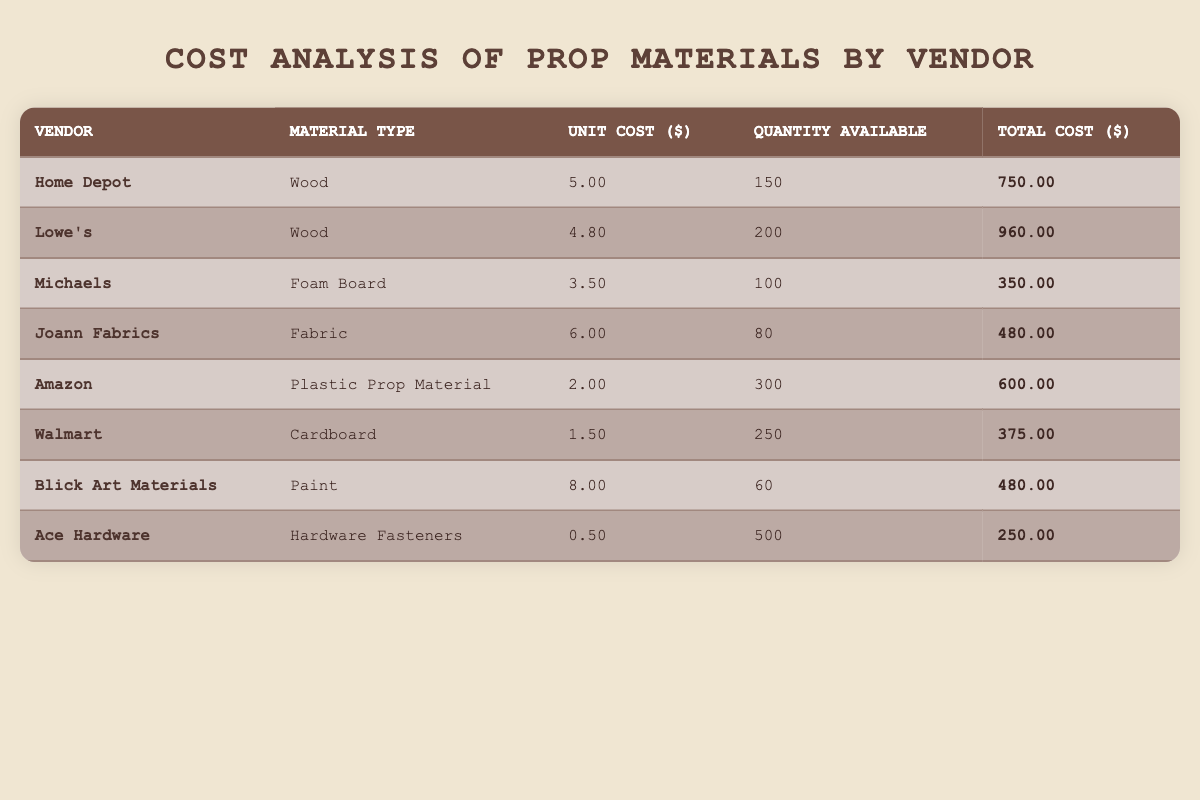What is the unit cost of Wood from Lowe's? The table lists Lowe's under the vendor column, and the corresponding unit cost, located in the same row, is $4.80.
Answer: 4.80 Which vendor offers the lowest unit cost for any material? The lowest unit cost listed in the table is for Ace Hardware offering Hardware Fasteners at $0.50, making it the vendor with the lowest unit cost for any material.
Answer: Ace Hardware How much more does it cost to buy 150 units of Wood from Home Depot compared to Walmart's Cardboard unit price? Home Depot's unit cost for Wood is $5.00; for Walmart's Cardboard, it's $1.50. The difference is $5.00 - $1.50 = $3.50. Therefore, for 150 units, the total cost at Home Depot would be 150 x $5.00 = $750.00 and at Walmart it would be 150 x $1.50 = $225.00. The difference in total cost is $750.00 - $225.00 = $525.00.
Answer: 525.00 Is the total cost of Fabirc from Joann Fabrics less than that of Foam Board from Michaels? Joann Fabrics' total cost for Fabric is $480, while Michaels' total cost for Foam Board is $350. Since $480 is greater than $350, the statement is false.
Answer: No What is the total number of units available across all vendors for Plastic Prop Material? The table indicates that Amazon offers 300 units of Plastic Prop Material, and it is the only vendor for this material. Therefore, the total number of units available is simply that figure: 300.
Answer: 300 What is the average unit cost of all materials listed in the table? To find the average unit cost, sum up all unit costs: 5.00 (Home Depot) + 4.80 (Lowe's) + 3.50 (Michaels) + 6.00 (Joann Fabrics) + 2.00 (Amazon) + 1.50 (Walmart) + 8.00 (Blick Art Materials) + 0.50 (Ace Hardware) = 31.30. Then, divide by the number of materials, which is 8. The average is 31.30 / 8 = 3.91.
Answer: 3.91 Which vendor has the highest quantity available, and how many units do they have? The vendor with the highest quantity available is Ace Hardware, listed with 500 units of Hardware Fasteners in the corresponding row of the table.
Answer: Ace Hardware; 500 What is the total cost of the materials from Blick Art Materials and Joann Fabrics combined? Blick Art Materials has a total cost of $480 for Paint and Joann Fabrics has a total cost of $480 for Fabric. Thus, the combined total is $480 + $480 = $960.
Answer: 960 